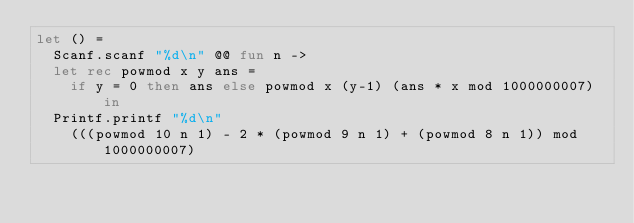Convert code to text. <code><loc_0><loc_0><loc_500><loc_500><_OCaml_>let () =
  Scanf.scanf "%d\n" @@ fun n ->
  let rec powmod x y ans = 
  	if y = 0 then ans else powmod x (y-1) (ans * x mod 1000000007) in
  Printf.printf "%d\n"
    (((powmod 10 n 1) - 2 * (powmod 9 n 1) + (powmod 8 n 1)) mod 1000000007)
</code> 